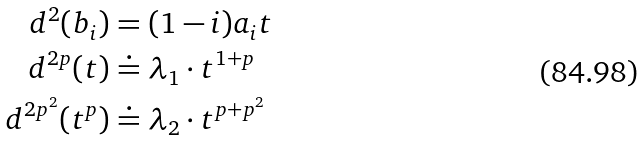<formula> <loc_0><loc_0><loc_500><loc_500>d ^ { 2 } ( b _ { i } ) & = ( 1 - i ) a _ { i } t \\ d ^ { 2 p } ( t ) & \doteq \lambda _ { 1 } \cdot t ^ { 1 + p } \\ d ^ { 2 p ^ { 2 } } ( t ^ { p } ) & \doteq \lambda _ { 2 } \cdot t ^ { p + p ^ { 2 } }</formula> 